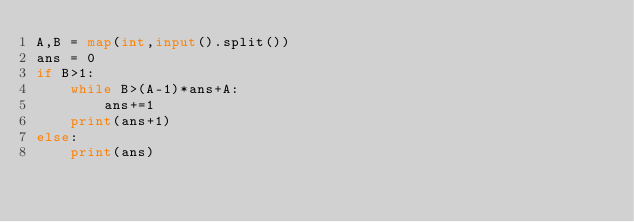<code> <loc_0><loc_0><loc_500><loc_500><_Python_>A,B = map(int,input().split())
ans = 0
if B>1:
    while B>(A-1)*ans+A:
        ans+=1
    print(ans+1)
else:
    print(ans)</code> 